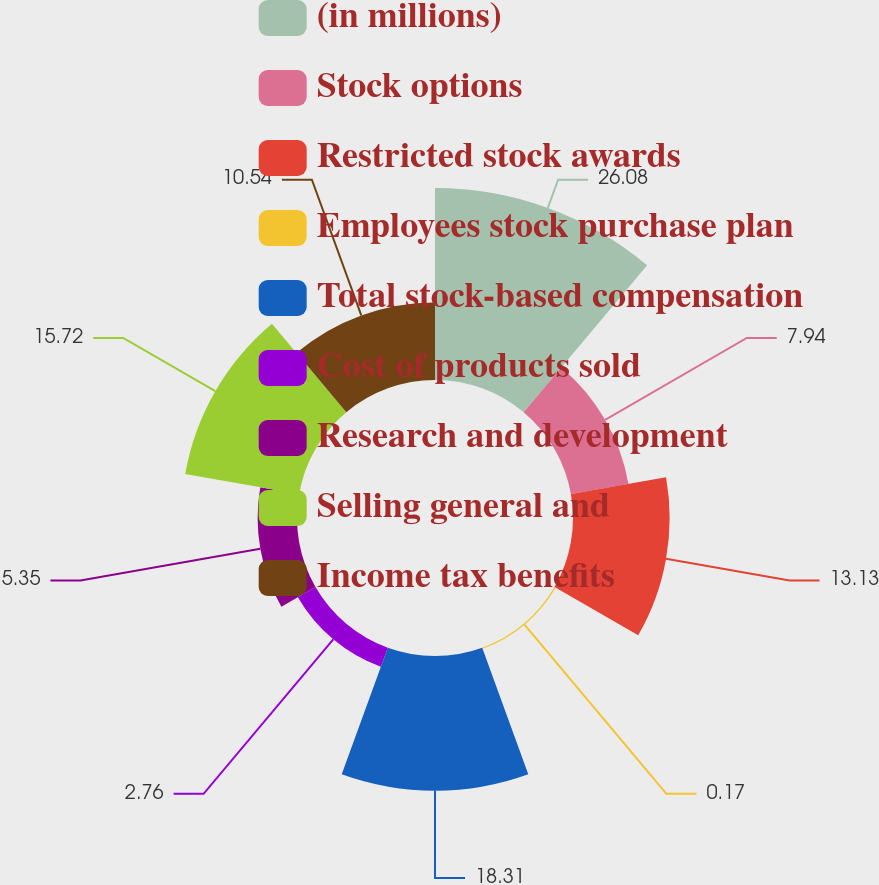Convert chart to OTSL. <chart><loc_0><loc_0><loc_500><loc_500><pie_chart><fcel>(in millions)<fcel>Stock options<fcel>Restricted stock awards<fcel>Employees stock purchase plan<fcel>Total stock-based compensation<fcel>Cost of products sold<fcel>Research and development<fcel>Selling general and<fcel>Income tax benefits<nl><fcel>26.09%<fcel>7.94%<fcel>13.13%<fcel>0.17%<fcel>18.31%<fcel>2.76%<fcel>5.35%<fcel>15.72%<fcel>10.54%<nl></chart> 